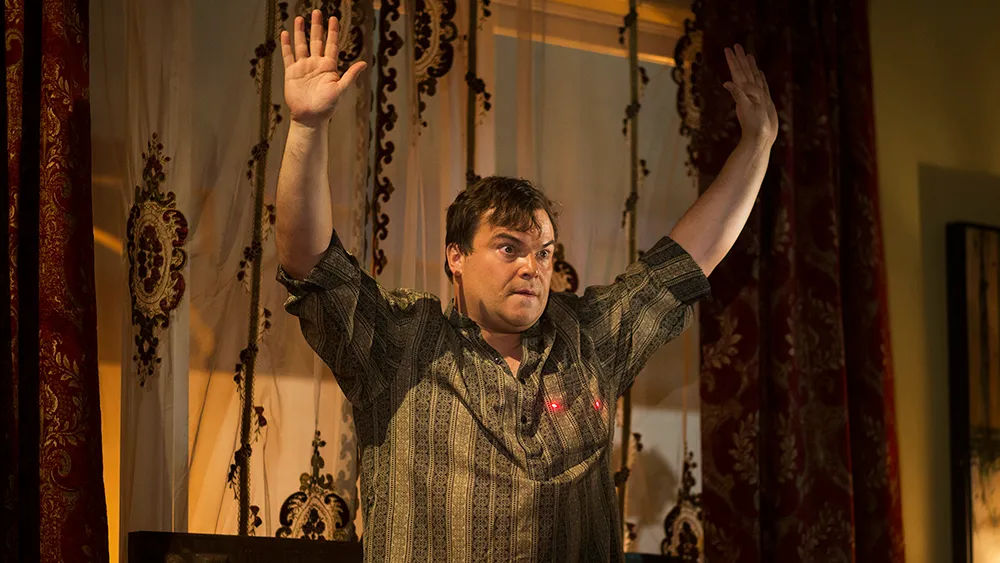What emotions can be interpreted from the man's expression and posture in this image? The man's expression and posture suggest a blend of surprise and engagement, possibly indicating an interactive moment in a performance. His raised hands and open stance could signify an appeal to or acknowledgment of an audience, while his eyes and slightly open mouth convey intensity and focus. 